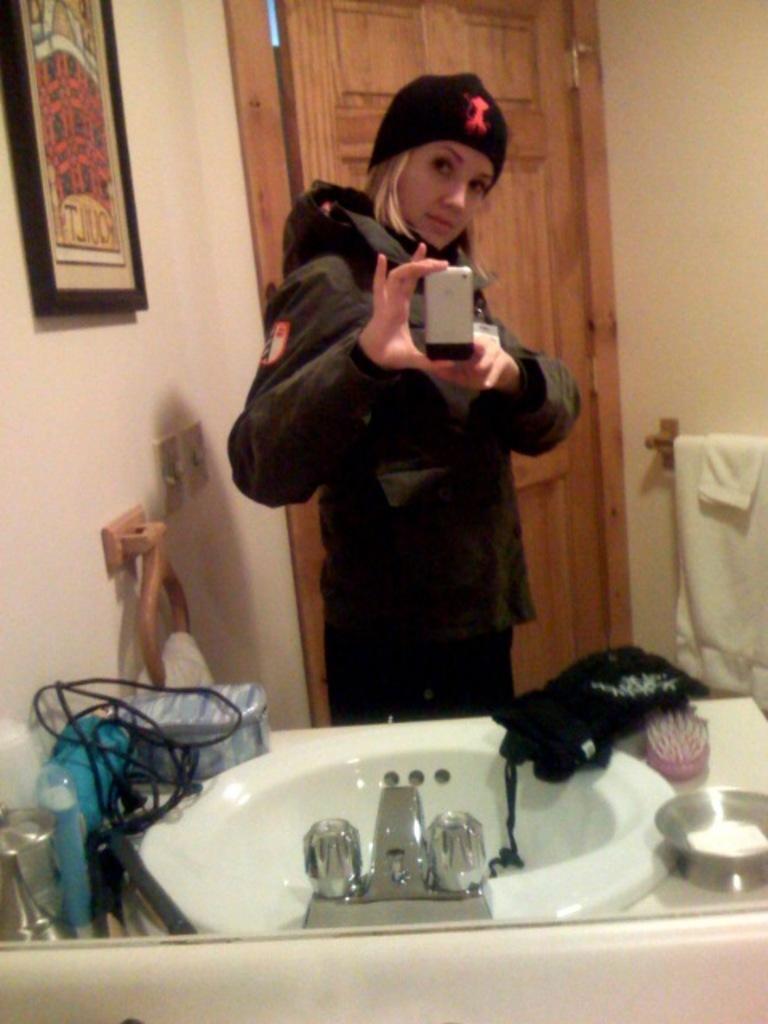Please provide a concise description of this image. In the image there is a woman in hoodie and cap taking selfie in a mirror with wash basin in front of her and behind her there is a door, on the left side there is a photograph on the wall with a switch board below it. 